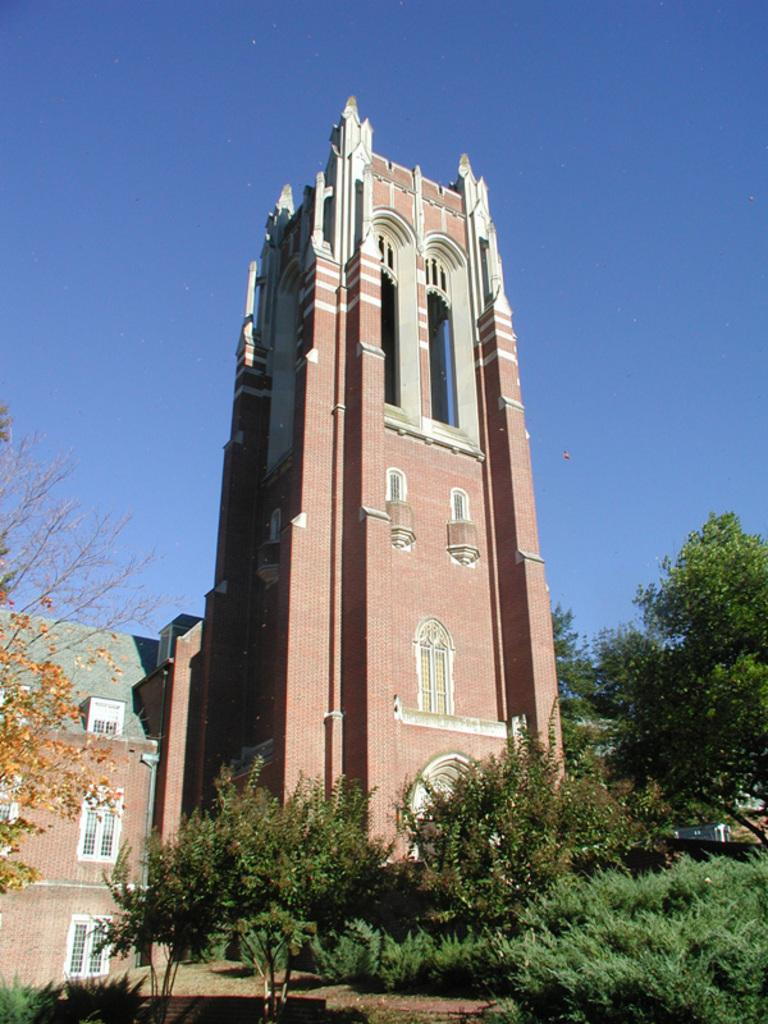What type of structure is visible in the image? There is a building in the image. What natural elements can be seen in the image? There are trees and plants in the image. What is the color of the sky in the image? The sky is blue in the image. What else can be found in the image besides the building, trees, and plants? There are objects in the image. How many plastic cent pieces are scattered on the ground in the image? There is no mention of plastic cent pieces in the image; they are not present. 